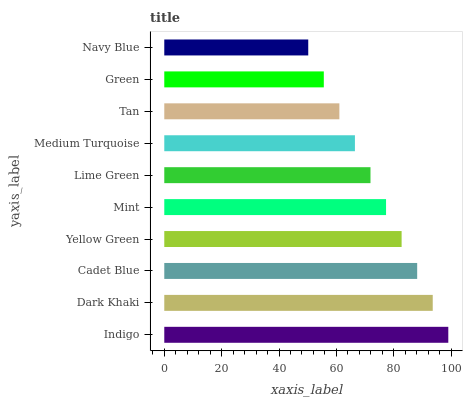Is Navy Blue the minimum?
Answer yes or no. Yes. Is Indigo the maximum?
Answer yes or no. Yes. Is Dark Khaki the minimum?
Answer yes or no. No. Is Dark Khaki the maximum?
Answer yes or no. No. Is Indigo greater than Dark Khaki?
Answer yes or no. Yes. Is Dark Khaki less than Indigo?
Answer yes or no. Yes. Is Dark Khaki greater than Indigo?
Answer yes or no. No. Is Indigo less than Dark Khaki?
Answer yes or no. No. Is Mint the high median?
Answer yes or no. Yes. Is Lime Green the low median?
Answer yes or no. Yes. Is Green the high median?
Answer yes or no. No. Is Navy Blue the low median?
Answer yes or no. No. 